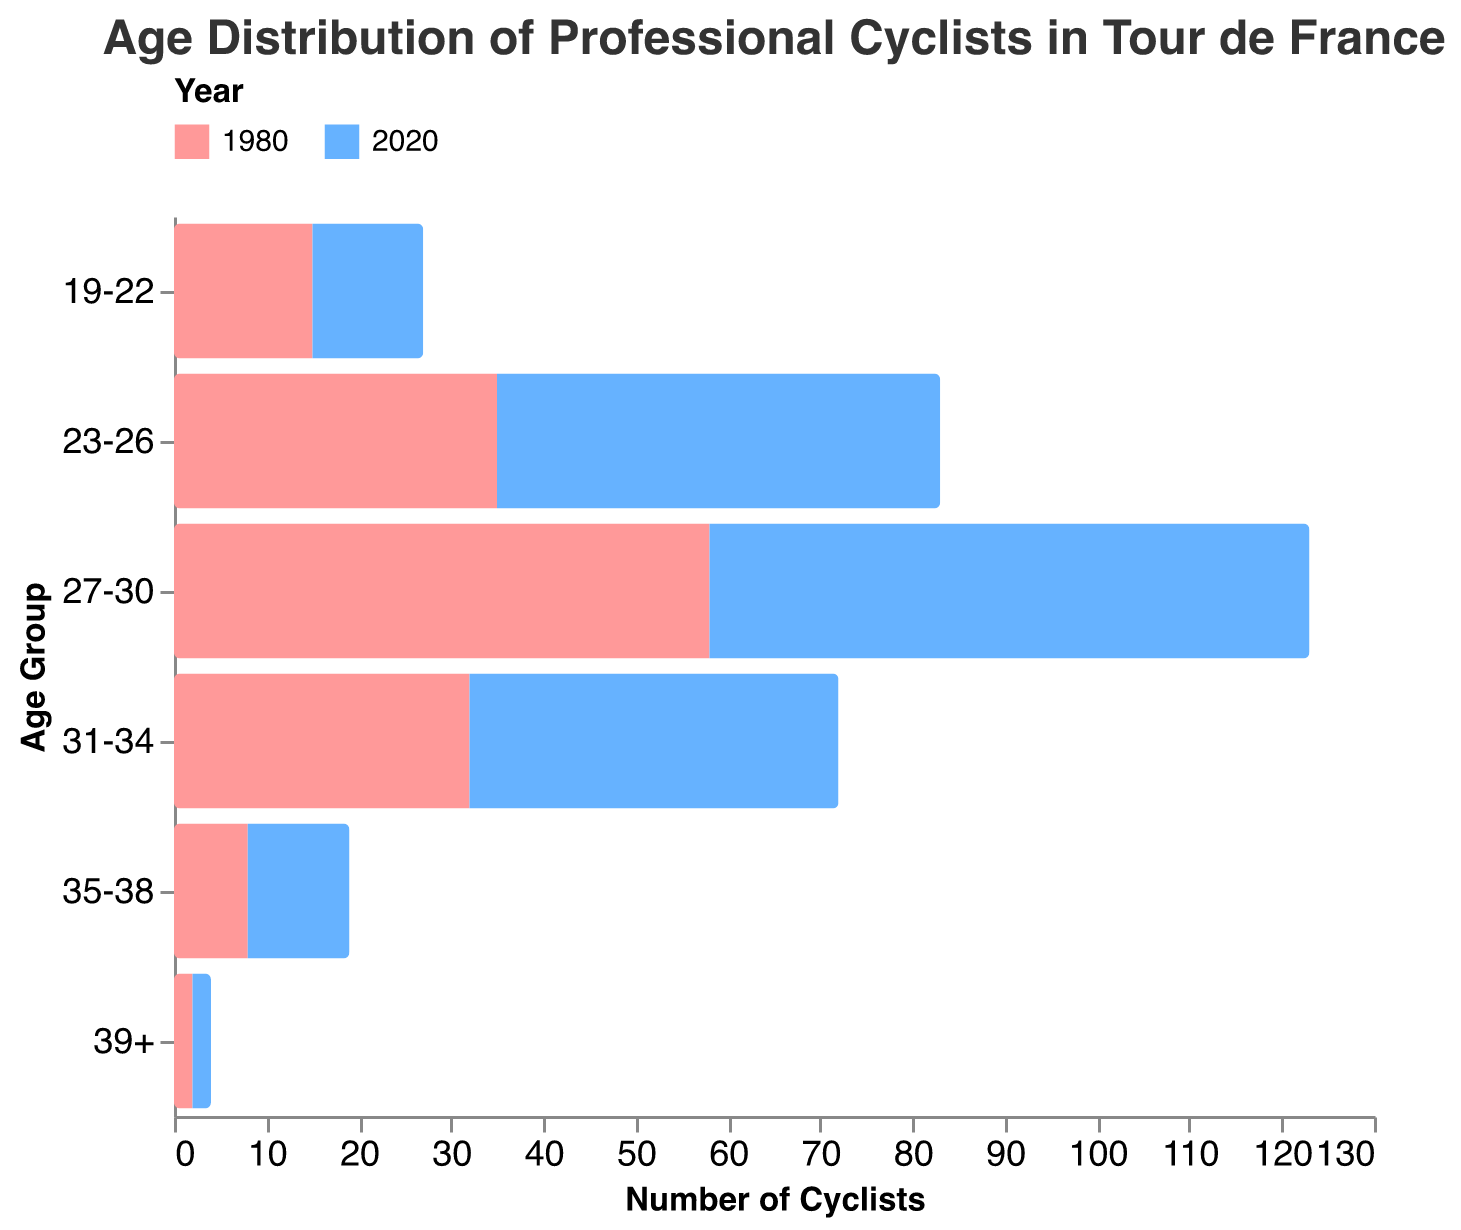How does the number of cyclists in the 23-26 age group in 2020 compare to that in 1980? The figure shows that in 1980 there were -35 cyclists in the 23-26 age group and 48 cyclists in 2020. The number of cyclists in 2020 is higher by 48 - (-35) = 83 cyclists.
Answer: 2020 has 83 more cyclists Which age group has the largest increase in the number of cyclists from 1980 to 2020? The largest change in the number of cyclists from 1980 to 2020 for each age group can be determined by looking at the differences. The differences are 19-22: 12 - (-15) = 27, 23-26: 48 - (-35) = 83, 27-30: 65 - (-58) = 123, 31-34: 40 - (-32) = 72, 35-38: 11 - (-8) = 19, 39+: 2 - (-2) = 4. The largest increase is in the 27-30 age group, with an increase of 123 cyclists.
Answer: 27-30 age group What is the total number of cyclists in 2020 for all age groups combined? Adding up the number of cyclists in 2020 for each age group: 12 + 48 + 65 + 40 + 11 + 2 = 178 cyclists.
Answer: 178 Which year had more cyclists in the 31-34 age group? According to the figure, the 31-34 age group had -32 cyclists in 1980 and 40 cyclists in 2020. Comparing these values, 2020 had more cyclists.
Answer: 2020 What is the age group with the least number of cyclists in 2020? The figure indicates the following number of cyclists in 2020: 19-22: 12, 23-26: 48, 27-30: 65, 31-34: 40, 35-38: 11, 39+: 2. The age group 39+ has the fewest cyclists with 2.
Answer: 39+ In 1980, how many more cyclists were in the 27-30 age group compared to the 23-26 age group? The number of cyclists in 1980 in the 27-30 age group was -58 and in the 23-26 age group was -35. The difference is -58 - (-35) = -23. Therefore, there are 23 more cyclists in the 23-26 age group compared to the 27-30 age group, as the numbers are negative and reflect the opposite.
Answer: 23 What is the overall trend of age distribution in professional cyclists from 1980 to 2020? Analyzing the figure, it’s evident that all age groups showed an increase in the number of cyclists from 1980 to 2020. The most significant increases were seen in the 23-30 age groups. This indicates a trend where the cycling population has grown across nearly all age brackets, with a notable rise in younger to mid-aged cyclists.
Answer: Increase across all age groups How many more cyclists are there in the 19-22 age group in 2020 compared to 1980? The number of cyclists in the 19-22 age group in 2020 is 12, and in 1980 it was -15. The increase can be calculated as 12 - (-15) = 27 cyclists.
Answer: 27 Which age group has the most similar number of cyclists between 1980 and 2020? The difference for each age group is calculated as follows: 19-22: 12 - (-15) = 27, 23-26: 48 - (-35) = 83, 27-30: 65 - (-58) = 123, 31-34: 40 - (-32) = 72, 35-38: 11 - (-8) = 19, 39+: 2 - (-2) = 4. The smallest difference is in the 39+ age group with a difference of 4 cyclists.
Answer: 39+ What is the mean number of cyclists per age group in 1980? To find the mean, sum all the cyclist numbers for each age group in 1980 and divide by the number of age groups: (-15) + (-35) + (-58) + (-32) + (-8) + (-2) = -150. There are 6 age groups, so the mean is -150 / 6 = -25 cyclists.
Answer: -25 